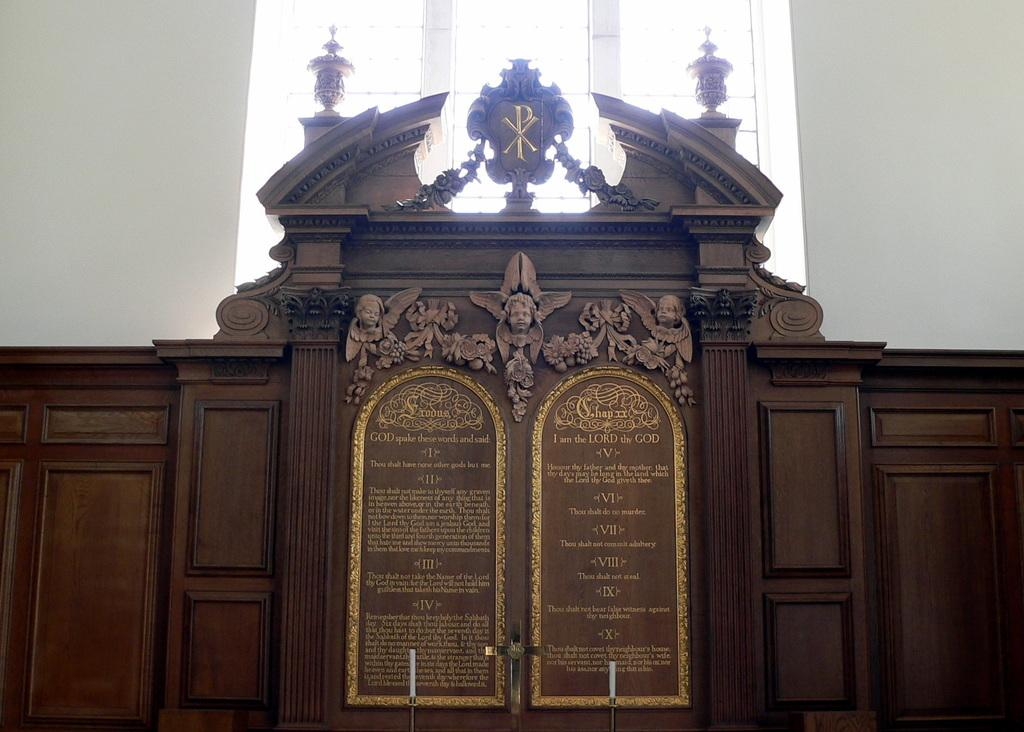What is the main object in the image? There is a museum plaque in the image. What can be found on the museum plaque? There is writing on the museum plaque. What else is depicted on the museum plaque? There are sculptures on the museum plaque. How many beams are supporting the museum plaque in the image? There is no beam present in the image; the museum plaque is likely mounted on a wall or display case. Is there a team of people depicted on the museum plaque? There is no team of people depicted on the museum plaque; it features writing and sculptures. 